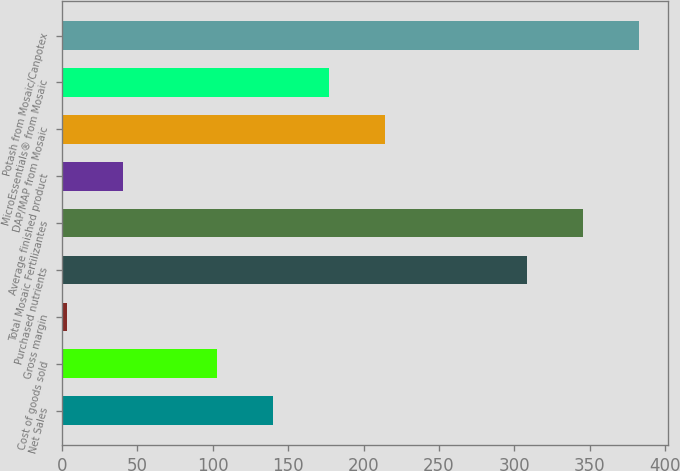Convert chart. <chart><loc_0><loc_0><loc_500><loc_500><bar_chart><fcel>Net Sales<fcel>Cost of goods sold<fcel>Gross margin<fcel>Purchased nutrients<fcel>Total Mosaic Fertilizantes<fcel>Average finished product<fcel>DAP/MAP from Mosaic<fcel>MicroEssentials® from Mosaic<fcel>Potash from Mosaic/Canpotex<nl><fcel>139.84<fcel>102.6<fcel>3.6<fcel>308<fcel>345.24<fcel>40.84<fcel>214.32<fcel>177.08<fcel>382.48<nl></chart> 